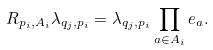Convert formula to latex. <formula><loc_0><loc_0><loc_500><loc_500>R _ { p _ { i } , A _ { i } } \lambda _ { q _ { j } , p _ { i } } = \lambda _ { q _ { j } , p _ { i } } \prod _ { a \in A _ { i } } e _ { a } .</formula> 